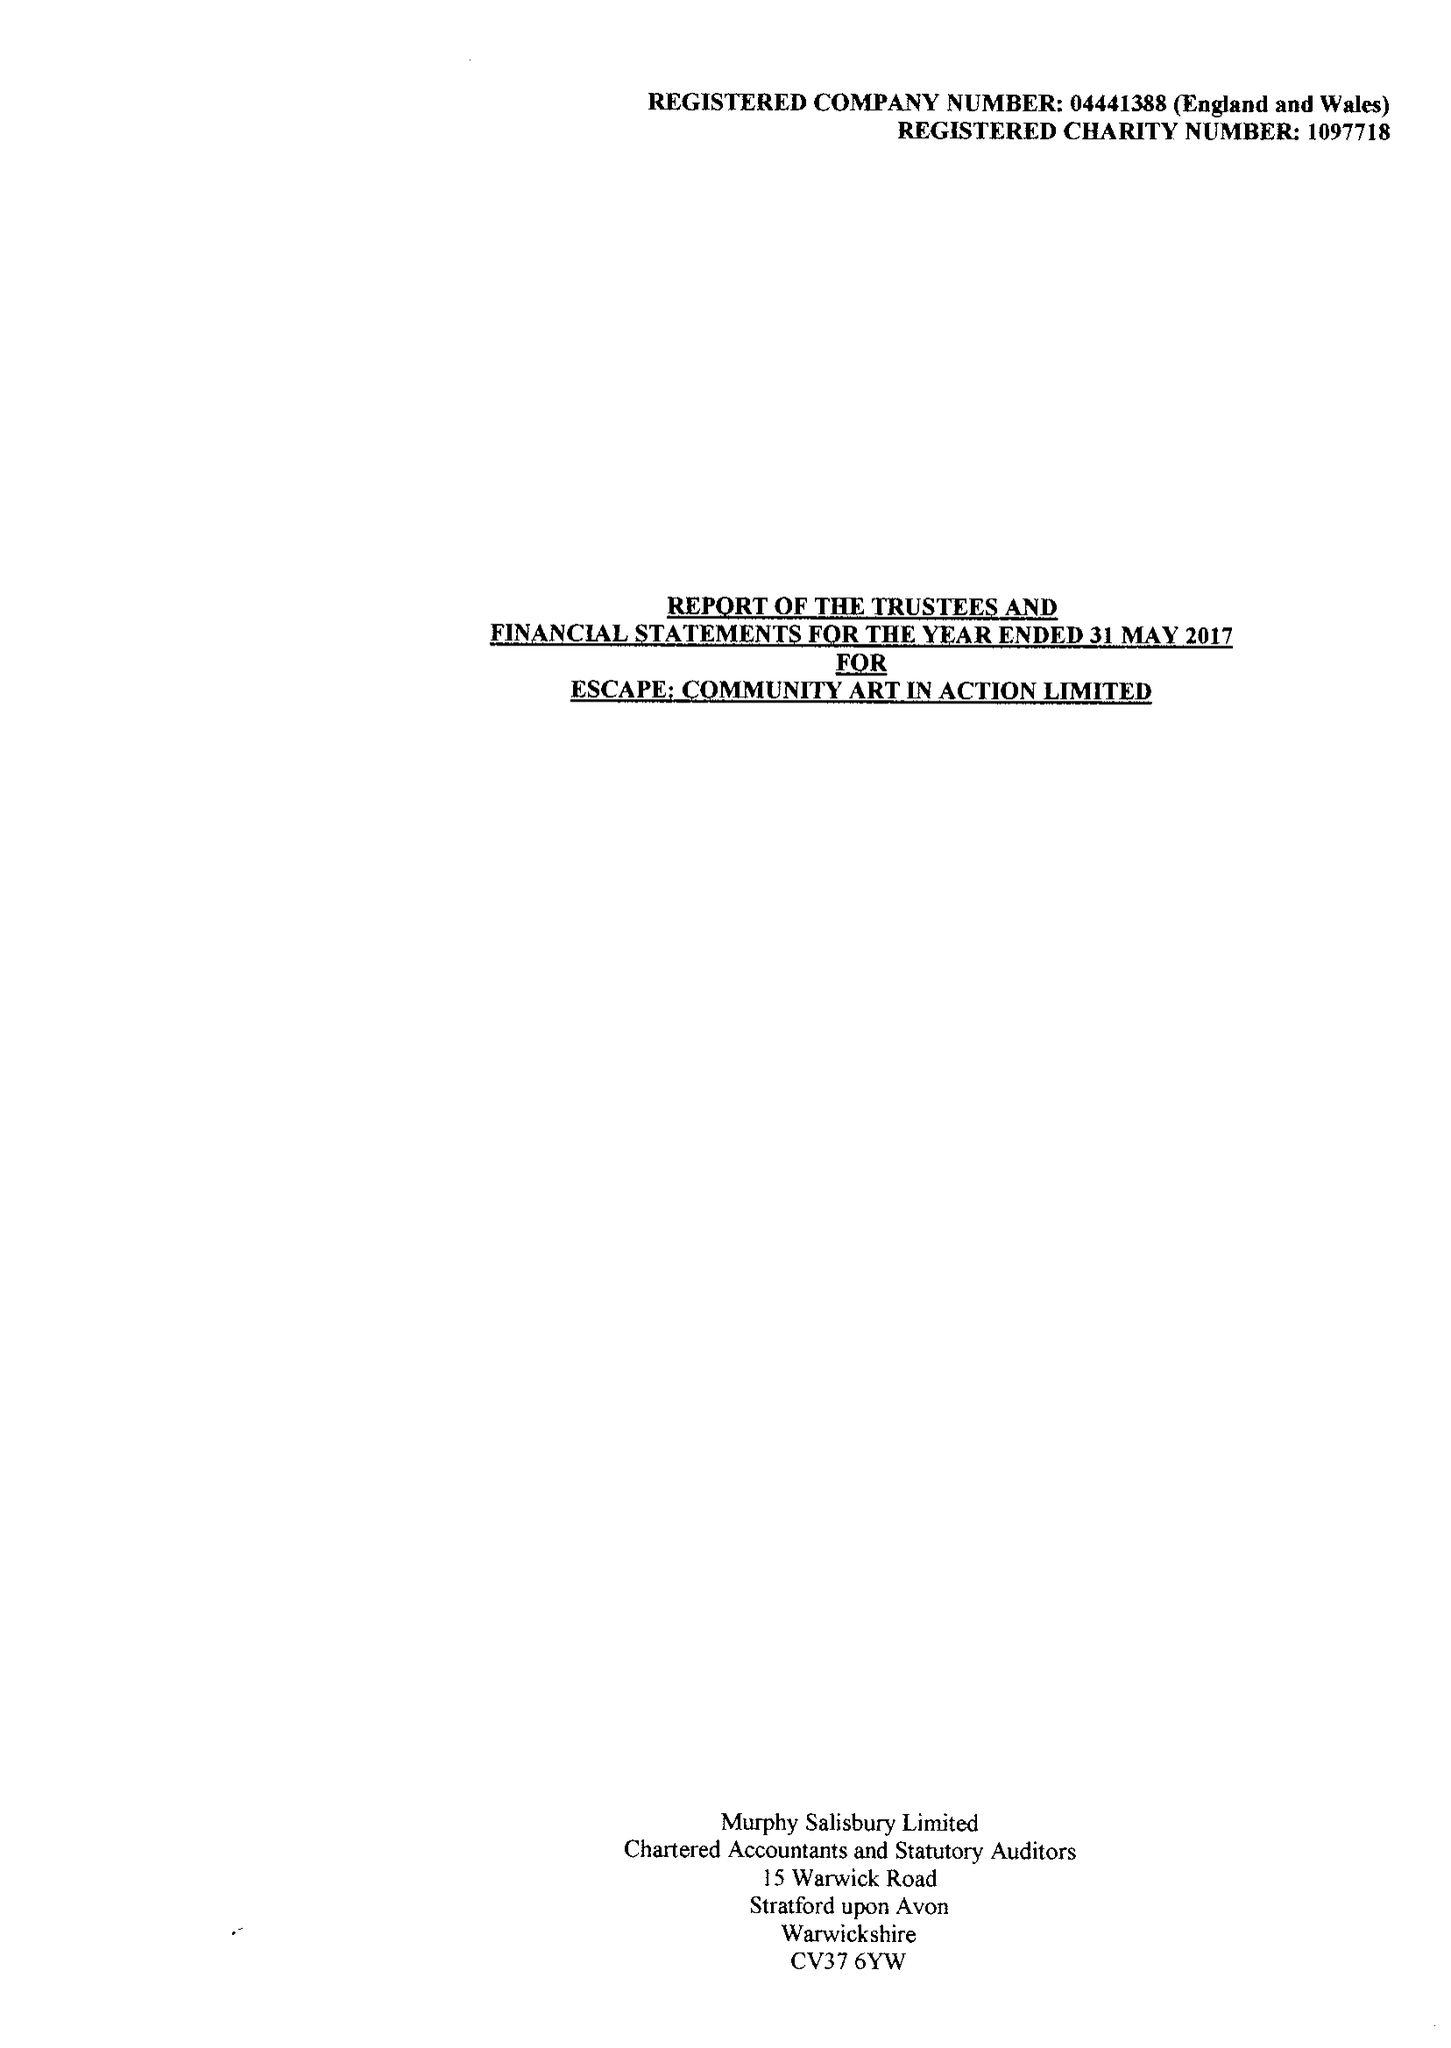What is the value for the address__post_town?
Answer the question using a single word or phrase. STRATFORD-UPON-AVON 